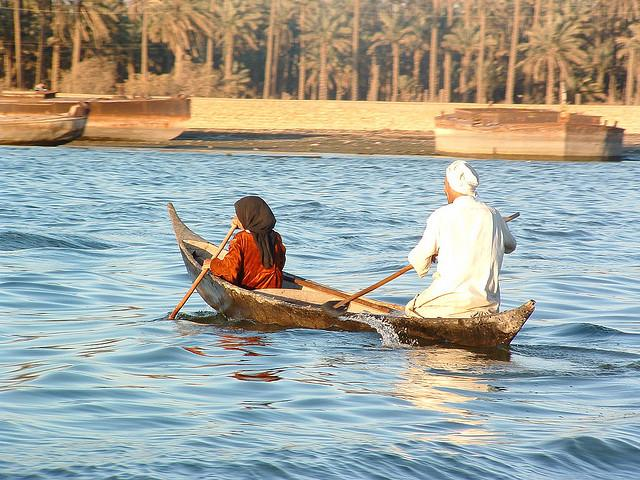What do the people have in their hands? Please explain your reasoning. paddles. Oars to move the boat in the water. 